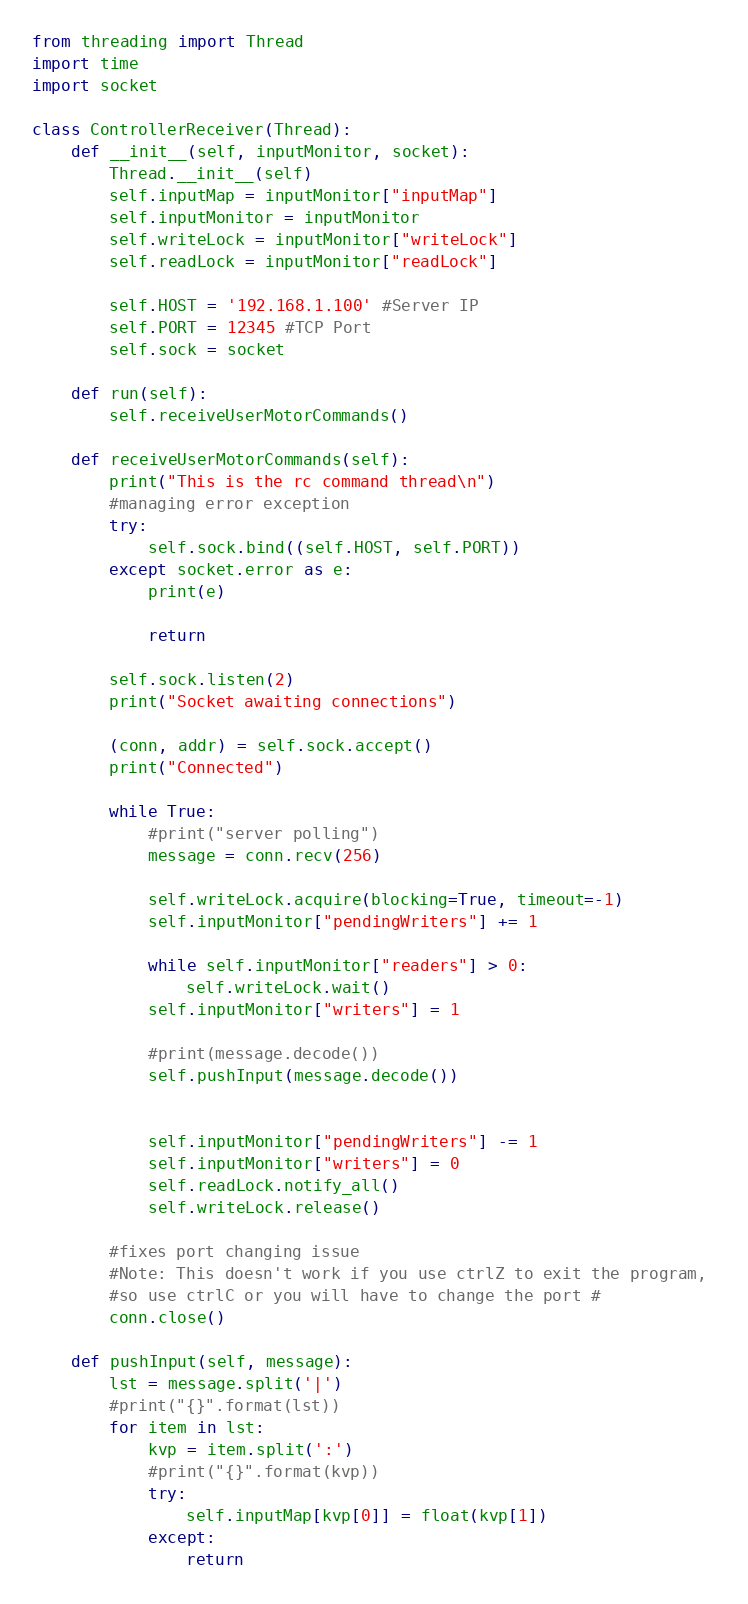Convert code to text. <code><loc_0><loc_0><loc_500><loc_500><_Python_>from threading import Thread
import time
import socket

class ControllerReceiver(Thread):
    def __init__(self, inputMonitor, socket):
        Thread.__init__(self)
        self.inputMap = inputMonitor["inputMap"]
        self.inputMonitor = inputMonitor
        self.writeLock = inputMonitor["writeLock"]
        self.readLock = inputMonitor["readLock"]
        
        self.HOST = '192.168.1.100' #Server IP
        self.PORT = 12345 #TCP Port
        self.sock = socket

    def run(self):
        self.receiveUserMotorCommands()
    
    def receiveUserMotorCommands(self):
        print("This is the rc command thread\n")
        #managing error exception
        try:
            self.sock.bind((self.HOST, self.PORT))
        except socket.error as e:
            print(e)
            
            return
            
        self.sock.listen(2)
        print("Socket awaiting connections")

        (conn, addr) = self.sock.accept()
        print("Connected")
        
        while True:
            #print("server polling")
            message = conn.recv(256)

            self.writeLock.acquire(blocking=True, timeout=-1)
            self.inputMonitor["pendingWriters"] += 1
            
            while self.inputMonitor["readers"] > 0:
                self.writeLock.wait()     
            self.inputMonitor["writers"] = 1
            
            #print(message.decode())
            self.pushInput(message.decode())

            
            self.inputMonitor["pendingWriters"] -= 1
            self.inputMonitor["writers"] = 0
            self.readLock.notify_all()
            self.writeLock.release()

        #fixes port changing issue
        #Note: This doesn't work if you use ctrlZ to exit the program,
        #so use ctrlC or you will have to change the port #            
        conn.close()            
    
    def pushInput(self, message):
        lst = message.split('|')
        #print("{}".format(lst))
        for item in lst:
            kvp = item.split(':')
            #print("{}".format(kvp))
            try:
                self.inputMap[kvp[0]] = float(kvp[1])
            except:
                return
</code> 